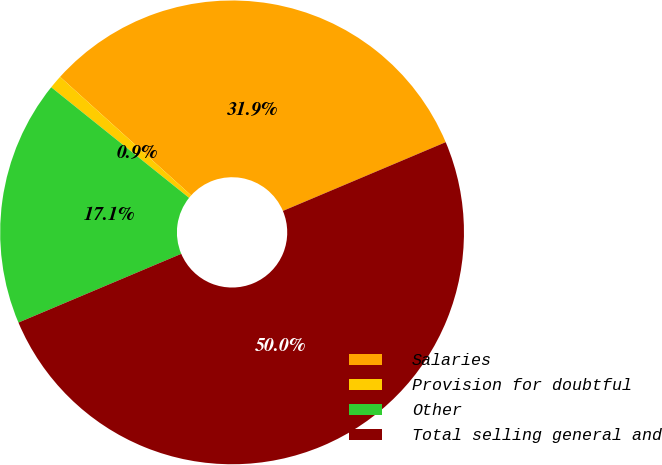Convert chart. <chart><loc_0><loc_0><loc_500><loc_500><pie_chart><fcel>Salaries<fcel>Provision for doubtful<fcel>Other<fcel>Total selling general and<nl><fcel>31.94%<fcel>0.94%<fcel>17.12%<fcel>50.0%<nl></chart> 